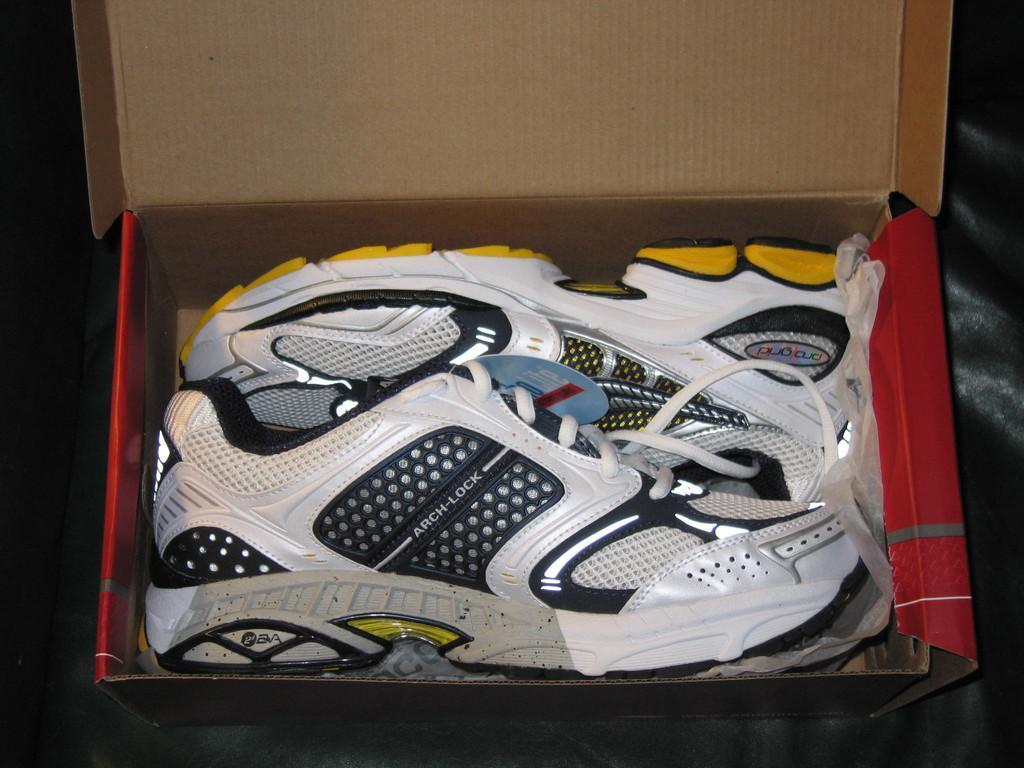Can you describe this image briefly? In this image it looks like a couch and on that we can see there are shoes in the box. 